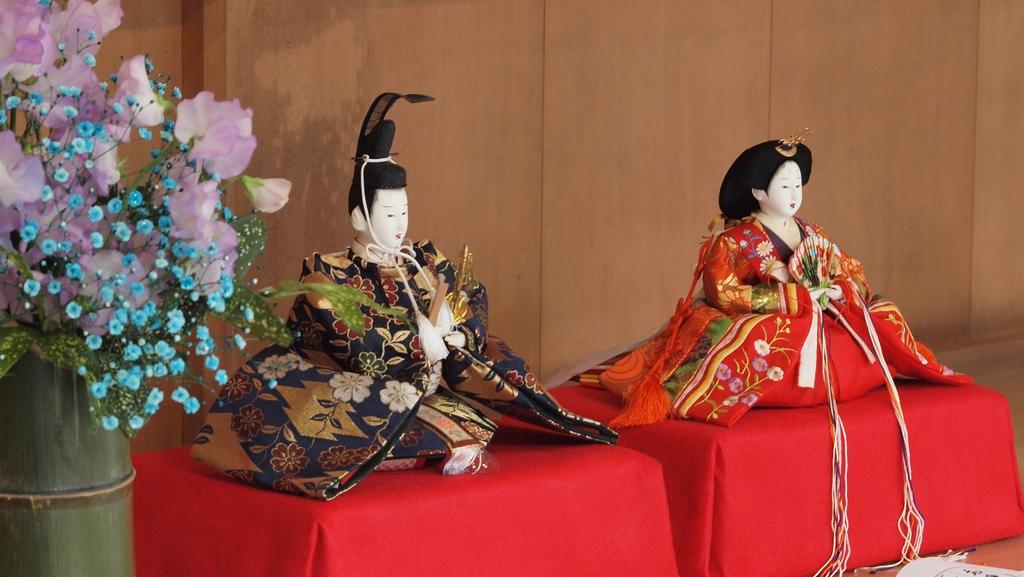How many statues can be seen in the image? There are two different statues in the image. Where might the statues be located? The statues are likely on a table. What is on the left side of the image? There is a flower pot on the left side of the image. What is inside the flower pot? There are flowers in the flower pot. What architectural feature can be seen in the image? There is a fence visible in the image. How many lizards are crawling on the statues in the image? There are no lizards present in the image; it only features statues, a flower pot, flowers, and a fence. What type of heat source can be seen in the image? There is no heat source visible in the image. 